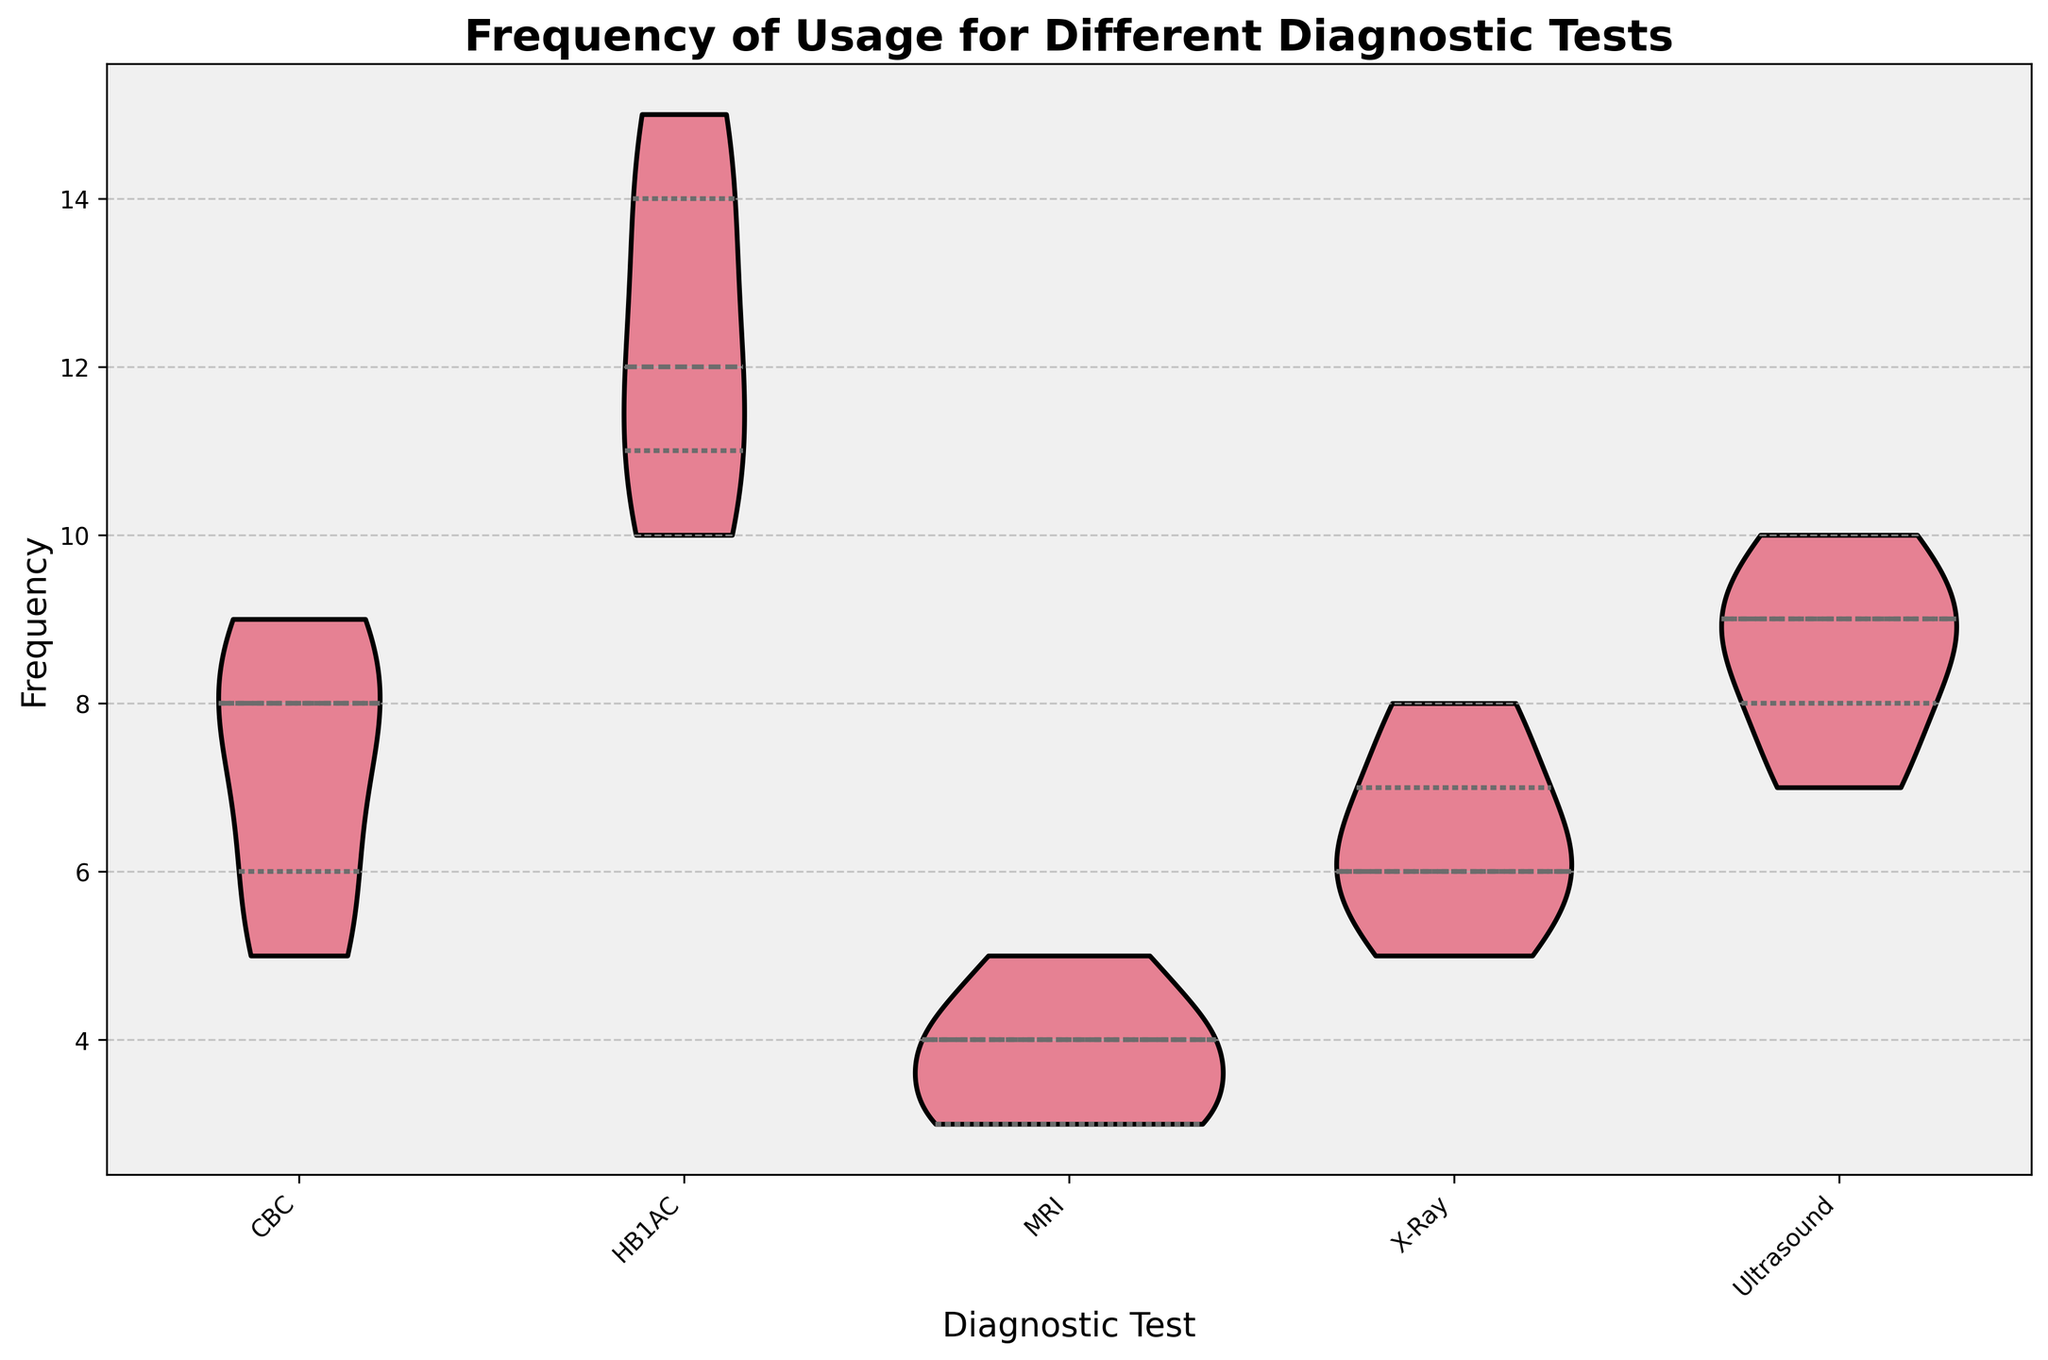What's the title of the figure? The title is written prominently at the top of the chart and provides a concise summary of what the chart is about.
Answer: Frequency of Usage for Different Diagnostic Tests Which diagnostic test shows the highest range of usage frequencies? By observing the spread of the violin plots for each diagnostic test, the one with the widest range indicates the highest variability in usage frequency.
Answer: HB1AC What's the frequency range for the MRI test? The frequency range can be deduced by observing the minimum and maximum values the MRI violin plot spans along the y-axis.
Answer: 3 to 5 How does the median usage frequency of CBC compare with that of X-Ray? The median is represented by a white dot or line within the violin plot. Comparing the positions of these medians on the y-axis for CBC and X-Ray shows which one is higher or lower.
Answer: The median usage frequency of CBC is higher than that of X-Ray How consistent is the frequency of Ultrasound usage compared to CBC? Consistency can be evaluated by observing how spread out the usage frequencies are within the violin plots. A narrower plot indicates more consistent usage, while a broader plot indicates more variability.
Answer: The frequency of Ultrasound usage is more consistent compared to CBC For which diagnostic test is the interquartile range the smallest? The interquartile range is denoted by the width of the dark portion inside the violin plot, representing the middle 50% of the data. The plot with the narrowest dark section has the smallest interquartile range.
Answer: MRI Between males and females, who appears to undergo HB1AC tests more frequently? By looking at breaking down the clusters inside the HB1AC violin plot, noting the median quartiles will indicate which gender has higher usage frequencies.
Answer: Females How does the frequency of usage for the X-Ray test vary among different age groups? To understand the variation among age groups, observe the shape and spread of the violin plot for the X-Ray test, identifying any notable concentrations or gaps.
Answer: Varies widely, with no clear concentration Which diagnostic test is used the least based on the median frequency? Median frequency is visualized by the central line or dot within the violin plots. The plot with the lowest median indicates the least usage.
Answer: MRI Are there any diagnostic tests where the frequencies show a bimodal distribution? Bimodal distribution is indicated by two distinct peaks in the violin plot. Identifying such peaks within the plots will answer this.
Answer: HB1AC 